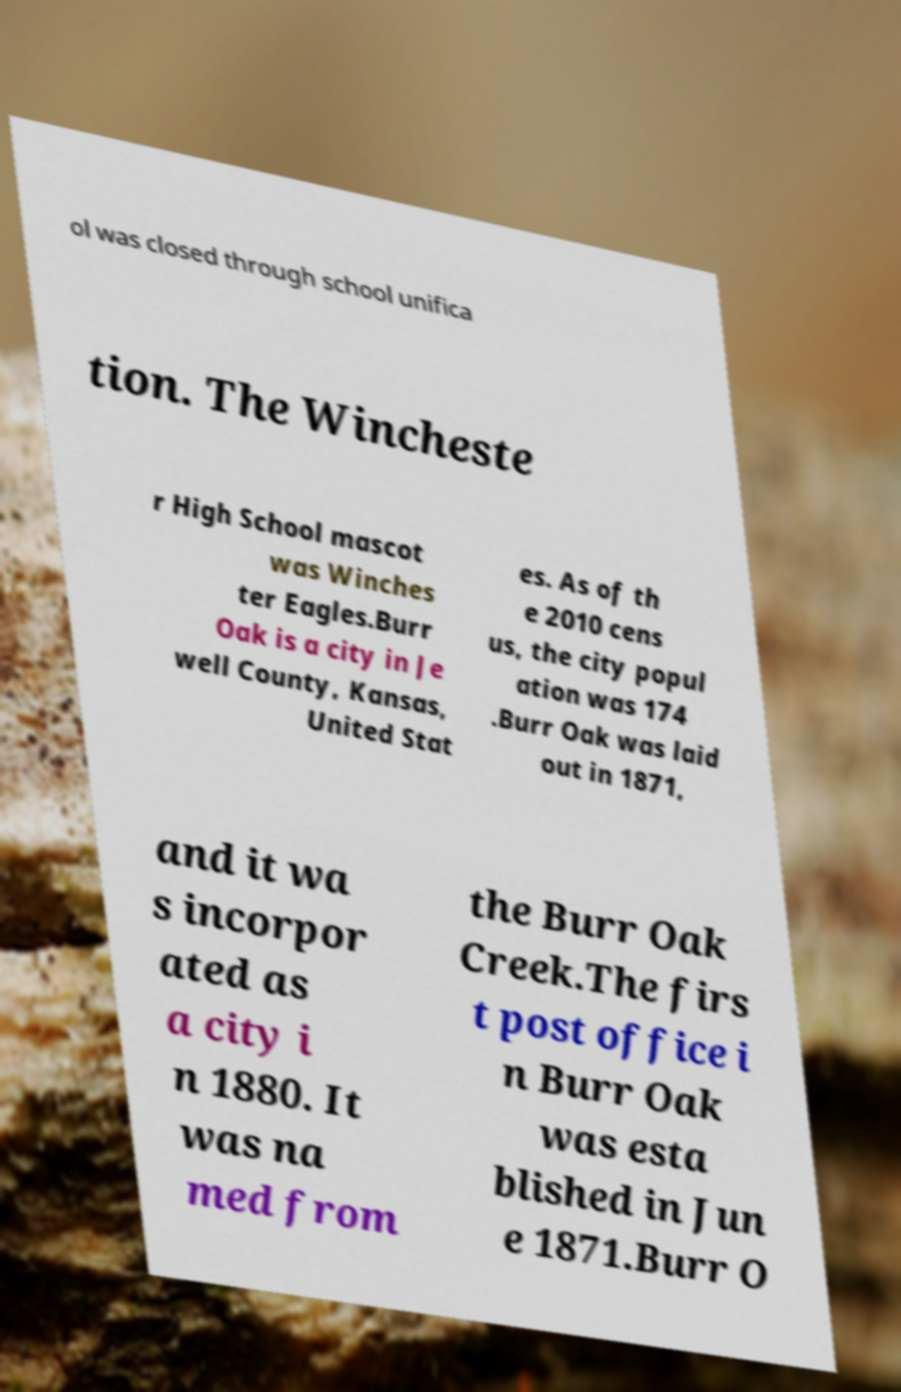There's text embedded in this image that I need extracted. Can you transcribe it verbatim? ol was closed through school unifica tion. The Wincheste r High School mascot was Winches ter Eagles.Burr Oak is a city in Je well County, Kansas, United Stat es. As of th e 2010 cens us, the city popul ation was 174 .Burr Oak was laid out in 1871, and it wa s incorpor ated as a city i n 1880. It was na med from the Burr Oak Creek.The firs t post office i n Burr Oak was esta blished in Jun e 1871.Burr O 